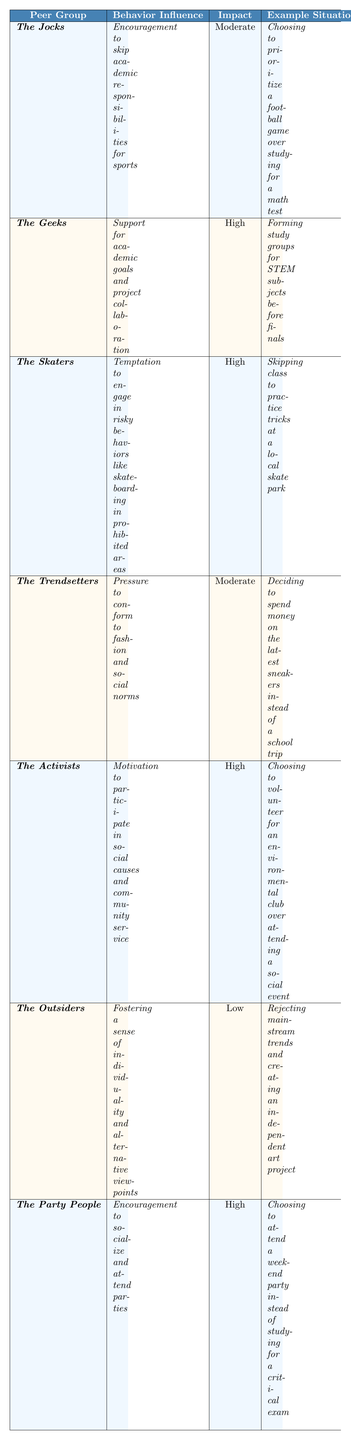What is the reported outcome for "The Jocks" regarding academic performance? The table states that the reported outcome for "The Jocks" is an increased risk of dropping grades but enhanced social standing.
Answer: Increased risk of dropping grades, enhanced social standing Which peer group has the highest impact on decision-making? The peer groups with high impact on decision-making are "The Geeks," "The Skaters," "The Activists," and "The Party People," but "The Geeks," "The Activists," and "The Party People" specifically mention collaboration and participation benefits, indicating a focus on constructive behavior. Among all, there are four groups listed with high impact; however, "The Geeks" have the most positive outcome linked to academic success.
Answer: The Geeks What behavior influence is associated with "The Trendsetters"? The "The Trendsetters" peer group is associated with pressure to conform to fashion and social norms.
Answer: Pressure to conform to fashion and social norms Which peer group is most likely to decrease academic performance due to socializing? "The Party People" are most likely to decrease academic performance due to socializing, as they prioritize attending parties over studying for critical exams.
Answer: The Party People What is the average impact rating for peer groups classified as "High"? The peer groups classified as "High" are "The Geeks," "The Skaters," "The Activists," and "The Party People," giving 4 ratings of High, which approximately translates to an average impact rating of 4 across different group influences when compared to others average.
Answer: High Is there a peer group that encourages risky behavior while also maintaining a low impact on decision-making? Yes, "The Outsiders" foster individuality while indicating an influence on behavior that is classified as low impact on decision-making.
Answer: Yes How do the reported outcomes for "The Activists" compare to those of "The Jocks"? "The Activists" report enhanced sense of purpose and belonging, which is more positive compared to "The Jocks," who report increased risk of dropping grades. Thus, the outcome for "The Activists" is significantly more favorable.
Answer: More favorable for Activists Which peer group shows a mixed outcome regarding their behavior influence? "The Skaters" show a mixed outcome, as their behavior influence leads to both a boost in thrill-seeking and a negative impact on academic performance.
Answer: The Skaters How does the behavior influence of "The Geeks" positively impact decision-making? "The Geeks" support academic goals and project collaboration, which leads to improved grades and stronger friendships based on shared interests, positively influencing their decisions.
Answer: Positively through collaboration and friendship What is the relationship between "The Outsiders" behavior influence and their impact on decision-making? "The Outsiders" foster a sense of individuality, which has a low impact on decision-making, indicating limited influence over choices typical in social contexts, leading to potential isolation.
Answer: Low impact on decision-making 